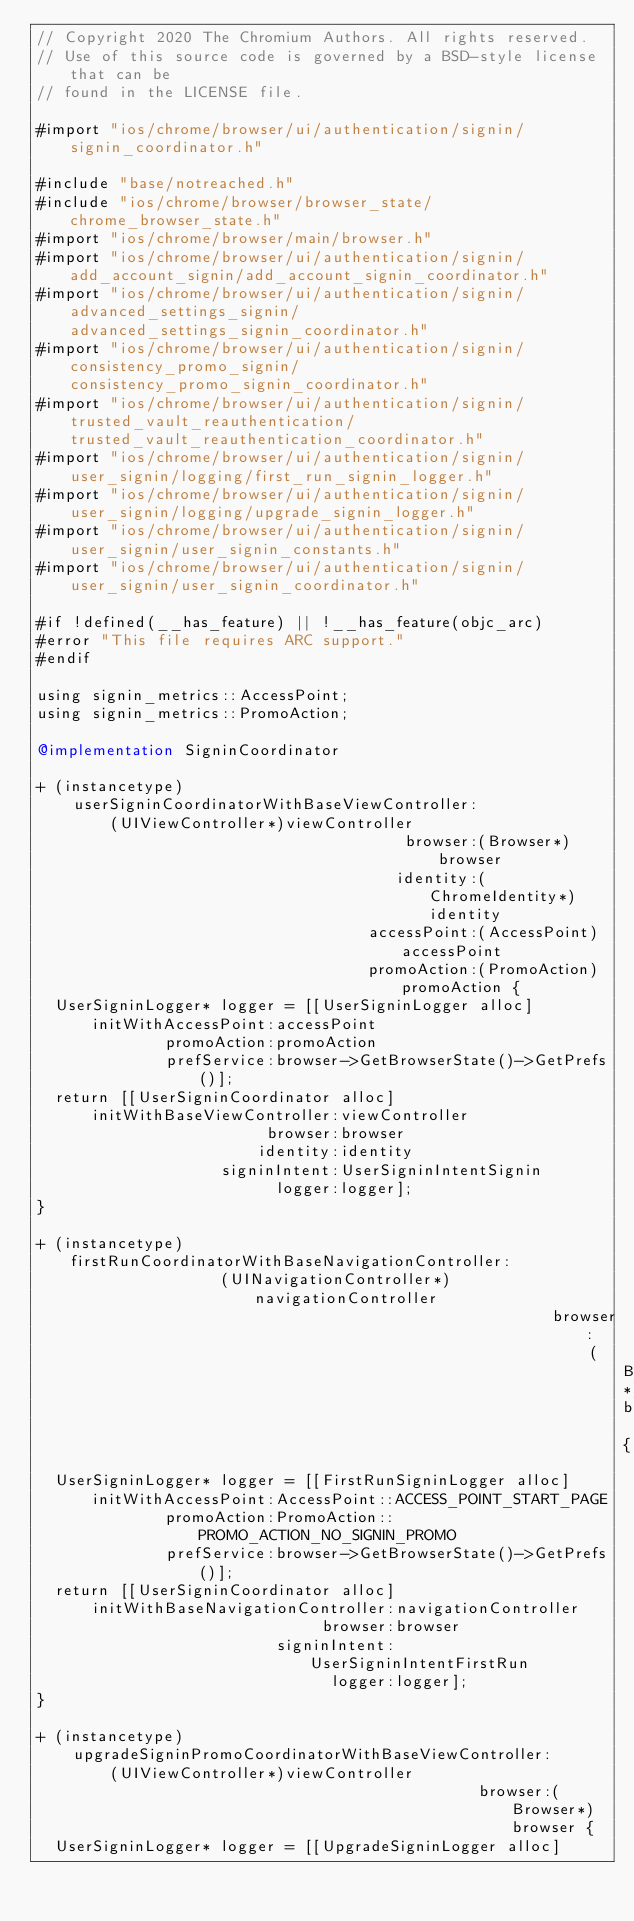<code> <loc_0><loc_0><loc_500><loc_500><_ObjectiveC_>// Copyright 2020 The Chromium Authors. All rights reserved.
// Use of this source code is governed by a BSD-style license that can be
// found in the LICENSE file.

#import "ios/chrome/browser/ui/authentication/signin/signin_coordinator.h"

#include "base/notreached.h"
#include "ios/chrome/browser/browser_state/chrome_browser_state.h"
#import "ios/chrome/browser/main/browser.h"
#import "ios/chrome/browser/ui/authentication/signin/add_account_signin/add_account_signin_coordinator.h"
#import "ios/chrome/browser/ui/authentication/signin/advanced_settings_signin/advanced_settings_signin_coordinator.h"
#import "ios/chrome/browser/ui/authentication/signin/consistency_promo_signin/consistency_promo_signin_coordinator.h"
#import "ios/chrome/browser/ui/authentication/signin/trusted_vault_reauthentication/trusted_vault_reauthentication_coordinator.h"
#import "ios/chrome/browser/ui/authentication/signin/user_signin/logging/first_run_signin_logger.h"
#import "ios/chrome/browser/ui/authentication/signin/user_signin/logging/upgrade_signin_logger.h"
#import "ios/chrome/browser/ui/authentication/signin/user_signin/user_signin_constants.h"
#import "ios/chrome/browser/ui/authentication/signin/user_signin/user_signin_coordinator.h"

#if !defined(__has_feature) || !__has_feature(objc_arc)
#error "This file requires ARC support."
#endif

using signin_metrics::AccessPoint;
using signin_metrics::PromoAction;

@implementation SigninCoordinator

+ (instancetype)
    userSigninCoordinatorWithBaseViewController:
        (UIViewController*)viewController
                                        browser:(Browser*)browser
                                       identity:(ChromeIdentity*)identity
                                    accessPoint:(AccessPoint)accessPoint
                                    promoAction:(PromoAction)promoAction {
  UserSigninLogger* logger = [[UserSigninLogger alloc]
      initWithAccessPoint:accessPoint
              promoAction:promoAction
              prefService:browser->GetBrowserState()->GetPrefs()];
  return [[UserSigninCoordinator alloc]
      initWithBaseViewController:viewController
                         browser:browser
                        identity:identity
                    signinIntent:UserSigninIntentSignin
                          logger:logger];
}

+ (instancetype)firstRunCoordinatorWithBaseNavigationController:
                    (UINavigationController*)navigationController
                                                        browser:
                                                            (Browser*)browser {
  UserSigninLogger* logger = [[FirstRunSigninLogger alloc]
      initWithAccessPoint:AccessPoint::ACCESS_POINT_START_PAGE
              promoAction:PromoAction::PROMO_ACTION_NO_SIGNIN_PROMO
              prefService:browser->GetBrowserState()->GetPrefs()];
  return [[UserSigninCoordinator alloc]
      initWithBaseNavigationController:navigationController
                               browser:browser
                          signinIntent:UserSigninIntentFirstRun
                                logger:logger];
}

+ (instancetype)
    upgradeSigninPromoCoordinatorWithBaseViewController:
        (UIViewController*)viewController
                                                browser:(Browser*)browser {
  UserSigninLogger* logger = [[UpgradeSigninLogger alloc]</code> 